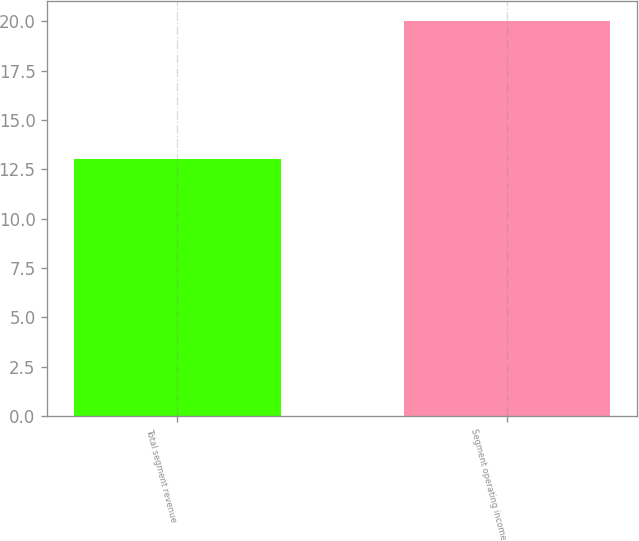Convert chart to OTSL. <chart><loc_0><loc_0><loc_500><loc_500><bar_chart><fcel>Total segment revenue<fcel>Segment operating income<nl><fcel>13<fcel>20<nl></chart> 